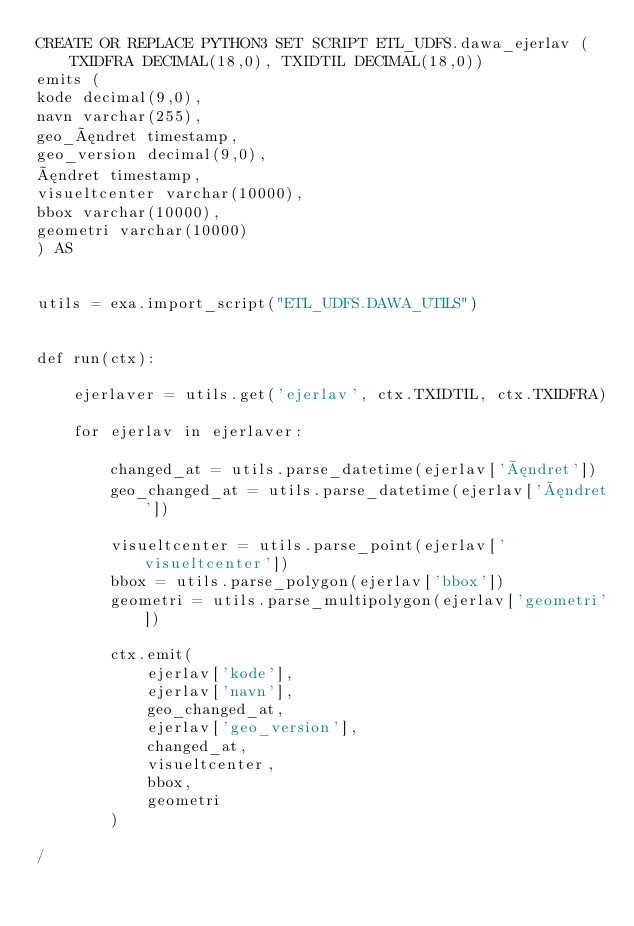Convert code to text. <code><loc_0><loc_0><loc_500><loc_500><_SQL_>CREATE OR REPLACE PYTHON3 SET SCRIPT ETL_UDFS.dawa_ejerlav (TXIDFRA DECIMAL(18,0), TXIDTIL DECIMAL(18,0))
emits (
kode decimal(9,0),
navn varchar(255),
geo_ændret timestamp,
geo_version decimal(9,0),
ændret timestamp,
visueltcenter varchar(10000),
bbox varchar(10000),
geometri varchar(10000)
) AS


utils = exa.import_script("ETL_UDFS.DAWA_UTILS")


def run(ctx):

    ejerlaver = utils.get('ejerlav', ctx.TXIDTIL, ctx.TXIDFRA)

    for ejerlav in ejerlaver:

        changed_at = utils.parse_datetime(ejerlav['ændret'])
        geo_changed_at = utils.parse_datetime(ejerlav['ændret'])

        visueltcenter = utils.parse_point(ejerlav['visueltcenter'])
        bbox = utils.parse_polygon(ejerlav['bbox'])
        geometri = utils.parse_multipolygon(ejerlav['geometri'])

        ctx.emit(
            ejerlav['kode'],
            ejerlav['navn'],
            geo_changed_at,
            ejerlav['geo_version'],
            changed_at,
            visueltcenter,
            bbox,
            geometri
        )

/
</code> 